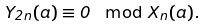<formula> <loc_0><loc_0><loc_500><loc_500>Y _ { 2 n } ( a ) \equiv 0 \mod { X _ { n } ( a ) } .</formula> 